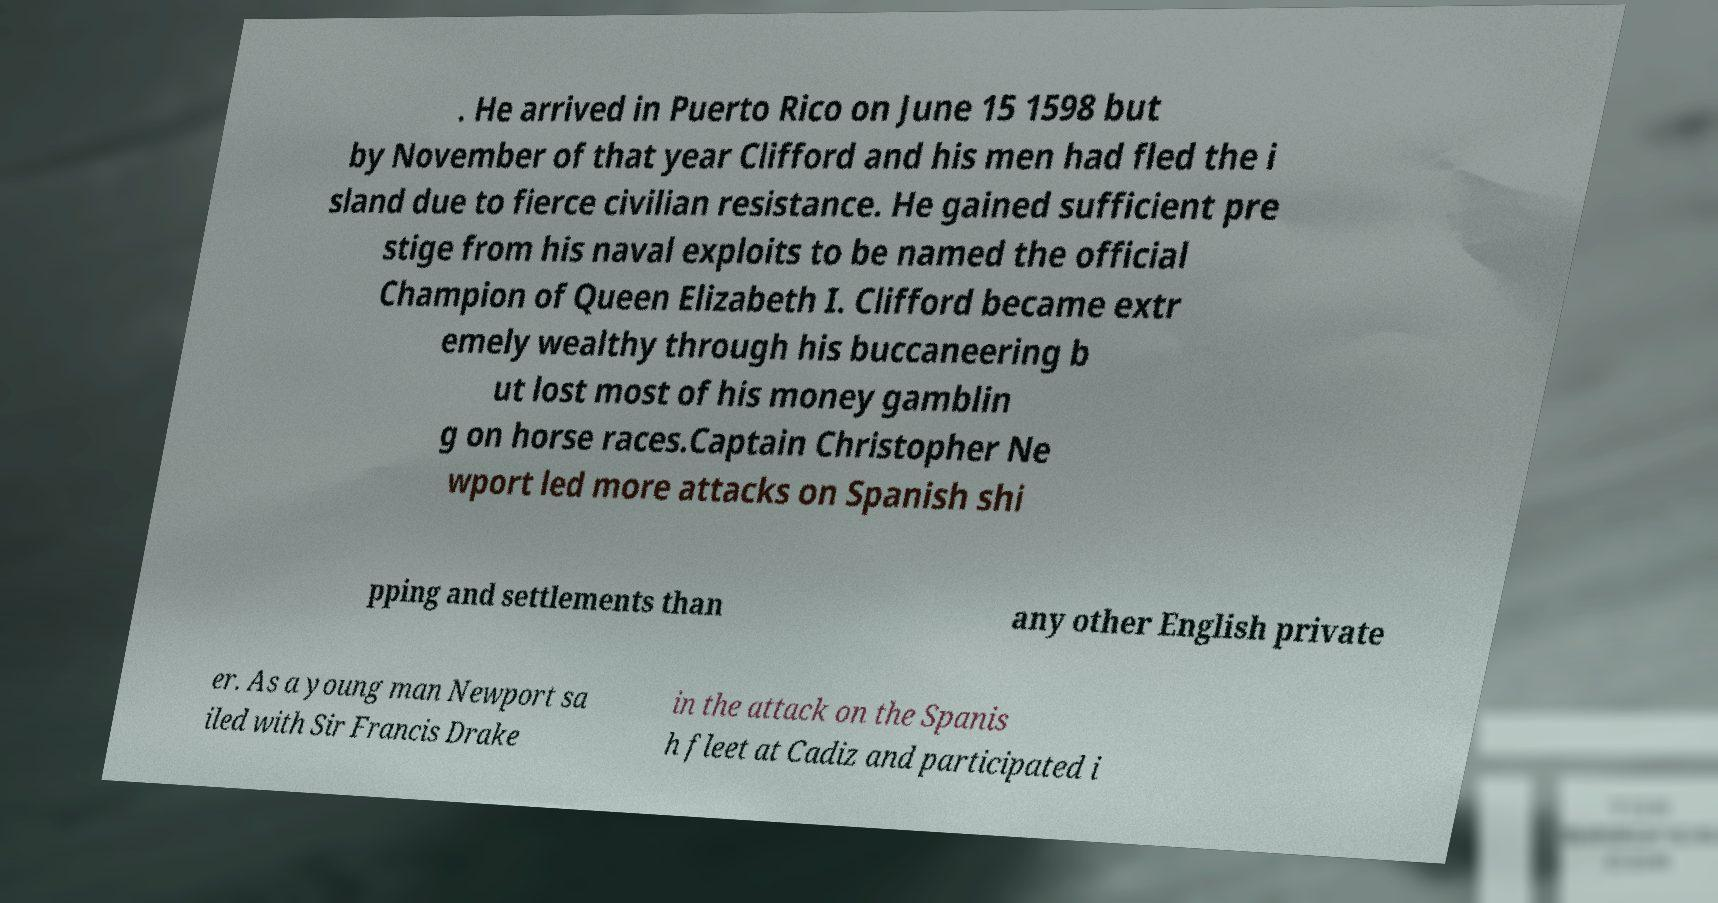What messages or text are displayed in this image? I need them in a readable, typed format. . He arrived in Puerto Rico on June 15 1598 but by November of that year Clifford and his men had fled the i sland due to fierce civilian resistance. He gained sufficient pre stige from his naval exploits to be named the official Champion of Queen Elizabeth I. Clifford became extr emely wealthy through his buccaneering b ut lost most of his money gamblin g on horse races.Captain Christopher Ne wport led more attacks on Spanish shi pping and settlements than any other English private er. As a young man Newport sa iled with Sir Francis Drake in the attack on the Spanis h fleet at Cadiz and participated i 